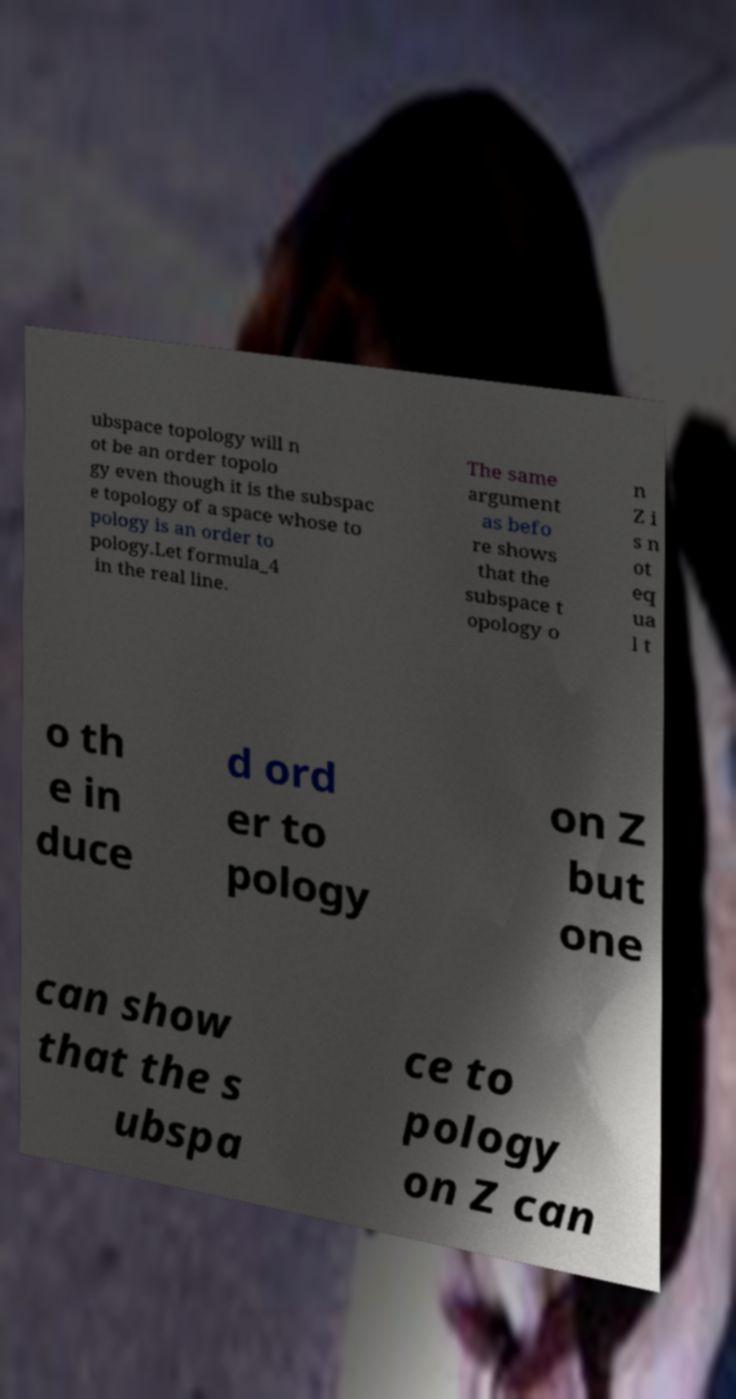Could you extract and type out the text from this image? ubspace topology will n ot be an order topolo gy even though it is the subspac e topology of a space whose to pology is an order to pology.Let formula_4 in the real line. The same argument as befo re shows that the subspace t opology o n Z i s n ot eq ua l t o th e in duce d ord er to pology on Z but one can show that the s ubspa ce to pology on Z can 